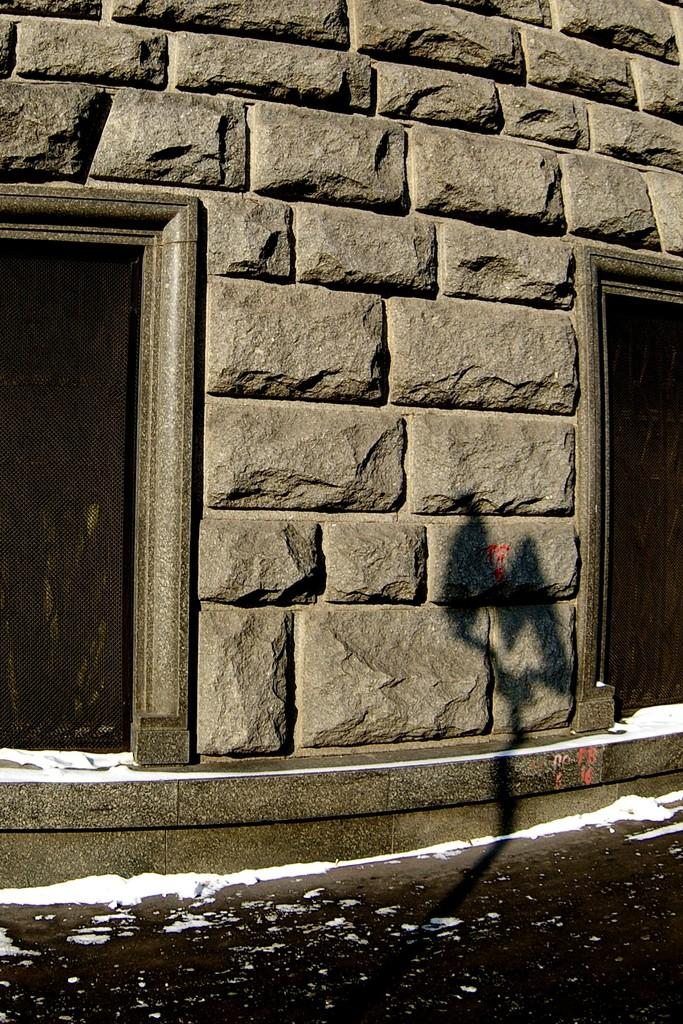What type of structure is visible in the image? There is a rock wall in the image. Are there any openings in the rock wall? Yes, there are windows visible in the image. What type of cloud can be seen in the image? There is no cloud present in the image; it only features a rock wall and windows. What color is the skin of the person in the image? There is no person present in the image, so we cannot determine the color of their skin. 